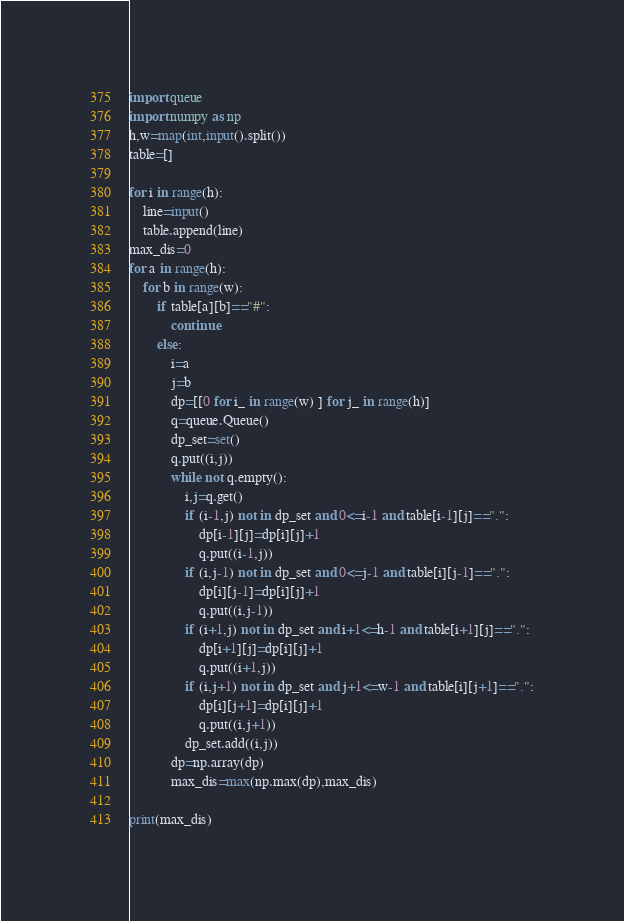<code> <loc_0><loc_0><loc_500><loc_500><_Python_>import queue
import numpy as np
h,w=map(int,input().split())
table=[]

for i in range(h):
    line=input()
    table.append(line)
max_dis=0
for a in range(h):
    for b in range(w):
        if table[a][b]=="#":
            continue
        else:
            i=a
            j=b
            dp=[[0 for i_ in range(w) ] for j_ in range(h)]
            q=queue.Queue()
            dp_set=set()
            q.put((i,j))
            while not q.empty():
                i,j=q.get()
                if (i-1,j) not in dp_set and 0<=i-1 and table[i-1][j]==".":
                    dp[i-1][j]=dp[i][j]+1
                    q.put((i-1,j))
                if (i,j-1) not in dp_set and 0<=j-1 and table[i][j-1]==".":
                    dp[i][j-1]=dp[i][j]+1
                    q.put((i,j-1))
                if (i+1,j) not in dp_set and i+1<=h-1 and table[i+1][j]==".":
                    dp[i+1][j]=dp[i][j]+1
                    q.put((i+1,j))
                if (i,j+1) not in dp_set and j+1<=w-1 and table[i][j+1]==".":
                    dp[i][j+1]=dp[i][j]+1    
                    q.put((i,j+1))
                dp_set.add((i,j))
            dp=np.array(dp)
            max_dis=max(np.max(dp),max_dis)
            
print(max_dis)</code> 